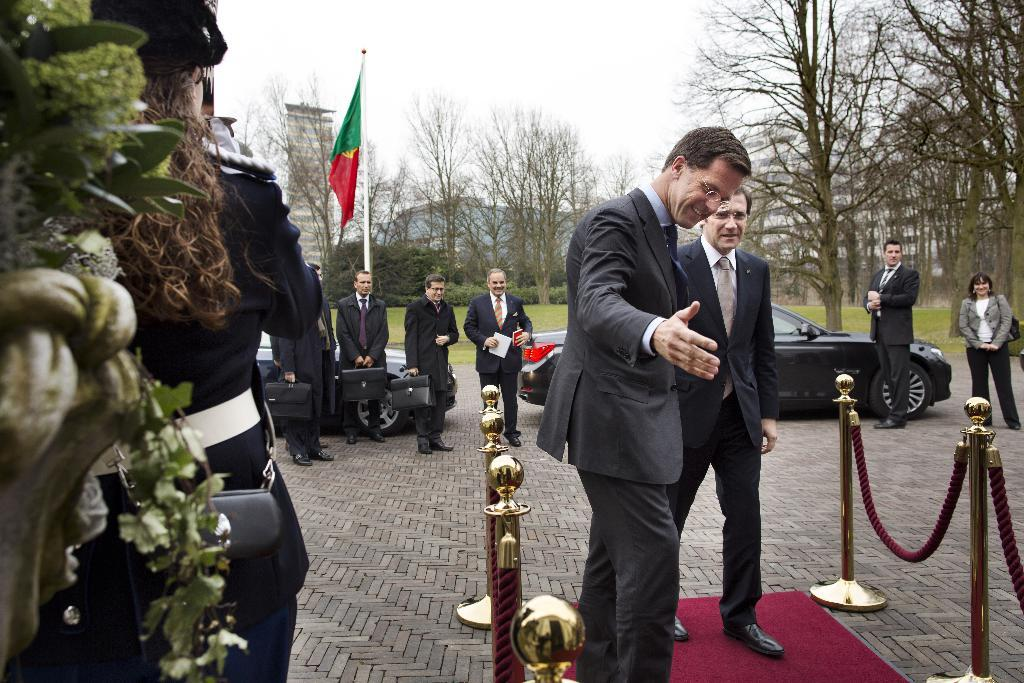How many people can be seen in the image? There are people in the image, but the exact number is not specified. What are some of the people holding in the image? Some of the people are holding bags in the image. What are the ropes tied to poles tied to used for? The purpose of the ropes tied ropes tied to poles is not specified in the image. What types of vehicles are present in the image? Vehicles are present in the image, but their specific types are not mentioned. What kind of structures can be seen in the image? There are buildings in the image. What type of vegetation is visible in the image? Trees are visible in the image. What is the flag in the image attached to? The flag in the image is attached to something, but the specific object is not mentioned. What can be seen in the sky in the image? The sky is visible in the image, but no specific details about the sky are provided. How many spiders are crawling on the bikes in the image? There are no bikes or spiders present in the image. What type of store can be seen in the image? There is no store present in the image. 